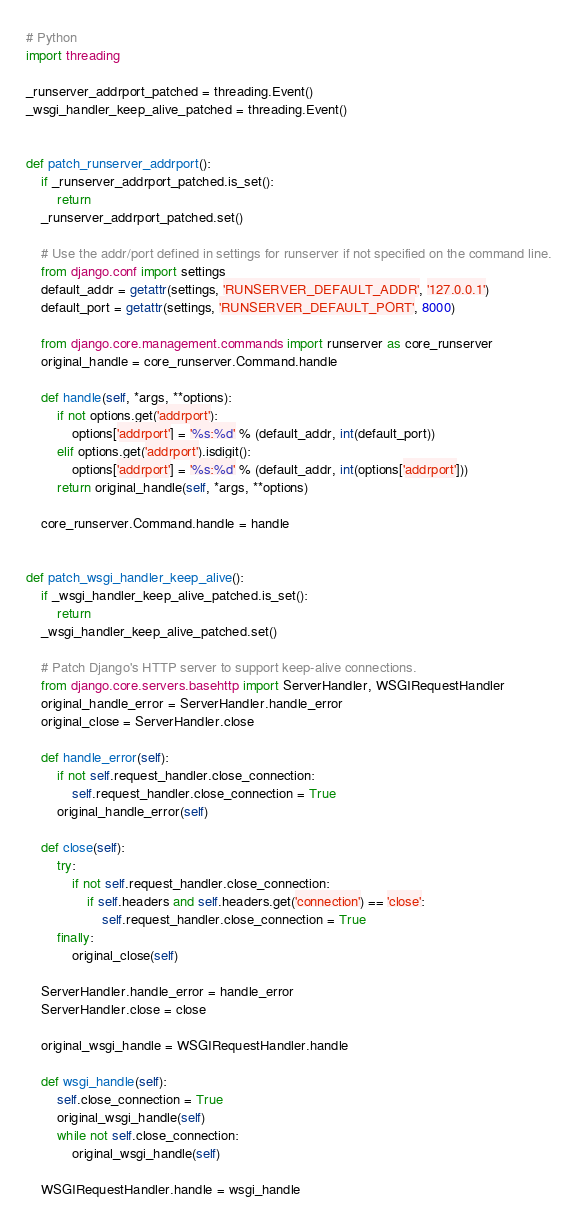Convert code to text. <code><loc_0><loc_0><loc_500><loc_500><_Python_># Python
import threading

_runserver_addrport_patched = threading.Event()
_wsgi_handler_keep_alive_patched = threading.Event()


def patch_runserver_addrport():
    if _runserver_addrport_patched.is_set():
        return
    _runserver_addrport_patched.set()

    # Use the addr/port defined in settings for runserver if not specified on the command line.
    from django.conf import settings
    default_addr = getattr(settings, 'RUNSERVER_DEFAULT_ADDR', '127.0.0.1')
    default_port = getattr(settings, 'RUNSERVER_DEFAULT_PORT', 8000)

    from django.core.management.commands import runserver as core_runserver
    original_handle = core_runserver.Command.handle

    def handle(self, *args, **options):
        if not options.get('addrport'):
            options['addrport'] = '%s:%d' % (default_addr, int(default_port))
        elif options.get('addrport').isdigit():
            options['addrport'] = '%s:%d' % (default_addr, int(options['addrport']))
        return original_handle(self, *args, **options)

    core_runserver.Command.handle = handle


def patch_wsgi_handler_keep_alive():
    if _wsgi_handler_keep_alive_patched.is_set():
        return
    _wsgi_handler_keep_alive_patched.set()

    # Patch Django's HTTP server to support keep-alive connections.
    from django.core.servers.basehttp import ServerHandler, WSGIRequestHandler
    original_handle_error = ServerHandler.handle_error
    original_close = ServerHandler.close

    def handle_error(self):
        if not self.request_handler.close_connection:
            self.request_handler.close_connection = True
        original_handle_error(self)

    def close(self):
        try:
            if not self.request_handler.close_connection:
                if self.headers and self.headers.get('connection') == 'close':
                    self.request_handler.close_connection = True
        finally:
            original_close(self)

    ServerHandler.handle_error = handle_error
    ServerHandler.close = close

    original_wsgi_handle = WSGIRequestHandler.handle

    def wsgi_handle(self):
        self.close_connection = True
        original_wsgi_handle(self)
        while not self.close_connection:
            original_wsgi_handle(self)

    WSGIRequestHandler.handle = wsgi_handle
</code> 